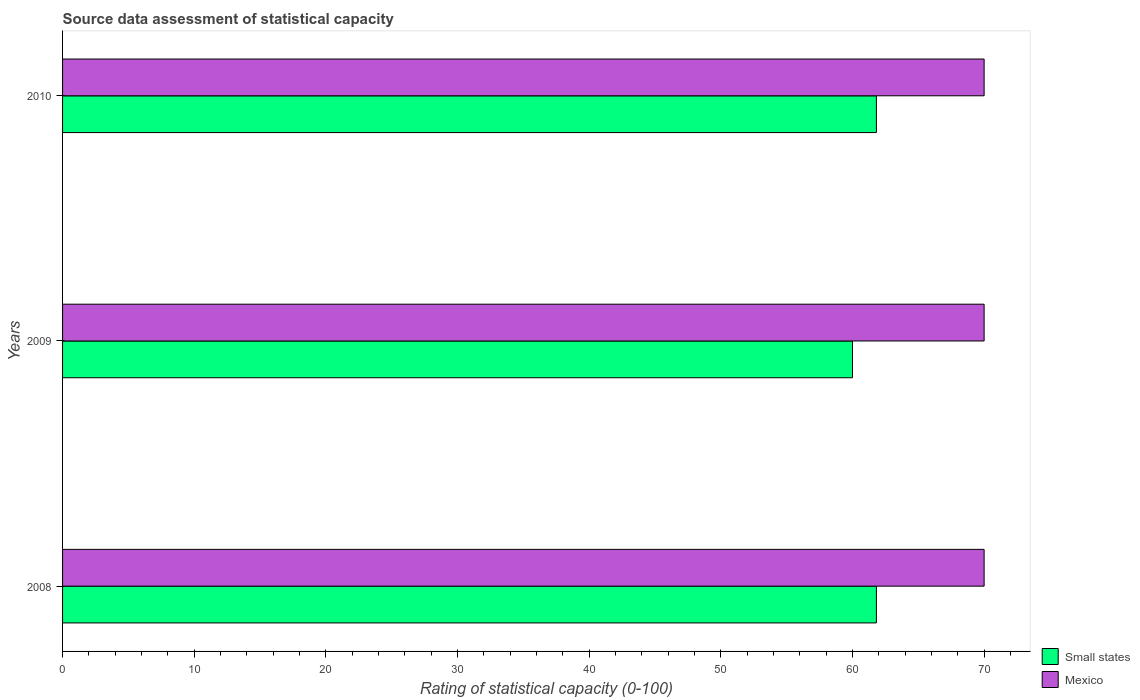How many different coloured bars are there?
Your response must be concise. 2. How many groups of bars are there?
Provide a short and direct response. 3. Are the number of bars per tick equal to the number of legend labels?
Your answer should be compact. Yes. How many bars are there on the 1st tick from the top?
Keep it short and to the point. 2. What is the label of the 2nd group of bars from the top?
Your answer should be compact. 2009. What is the rating of statistical capacity in Mexico in 2010?
Make the answer very short. 70. Across all years, what is the maximum rating of statistical capacity in Mexico?
Offer a terse response. 70. Across all years, what is the minimum rating of statistical capacity in Small states?
Your answer should be very brief. 60. What is the total rating of statistical capacity in Small states in the graph?
Your answer should be compact. 183.64. What is the difference between the rating of statistical capacity in Mexico in 2008 and that in 2009?
Offer a very short reply. 0. What is the difference between the rating of statistical capacity in Small states in 2010 and the rating of statistical capacity in Mexico in 2008?
Keep it short and to the point. -8.18. What is the average rating of statistical capacity in Small states per year?
Offer a very short reply. 61.21. In how many years, is the rating of statistical capacity in Mexico greater than 14 ?
Your response must be concise. 3. Is the rating of statistical capacity in Small states in 2008 less than that in 2010?
Keep it short and to the point. No. What is the difference between the highest and the lowest rating of statistical capacity in Small states?
Ensure brevity in your answer.  1.82. Is the sum of the rating of statistical capacity in Small states in 2009 and 2010 greater than the maximum rating of statistical capacity in Mexico across all years?
Offer a very short reply. Yes. What does the 2nd bar from the top in 2009 represents?
Your answer should be very brief. Small states. What does the 2nd bar from the bottom in 2008 represents?
Offer a very short reply. Mexico. How many bars are there?
Offer a terse response. 6. How many years are there in the graph?
Make the answer very short. 3. What is the difference between two consecutive major ticks on the X-axis?
Provide a short and direct response. 10. Does the graph contain any zero values?
Your answer should be compact. No. Does the graph contain grids?
Your answer should be very brief. No. Where does the legend appear in the graph?
Provide a short and direct response. Bottom right. What is the title of the graph?
Provide a succinct answer. Source data assessment of statistical capacity. Does "Middle East & North Africa (developing only)" appear as one of the legend labels in the graph?
Your answer should be very brief. No. What is the label or title of the X-axis?
Make the answer very short. Rating of statistical capacity (0-100). What is the Rating of statistical capacity (0-100) in Small states in 2008?
Give a very brief answer. 61.82. What is the Rating of statistical capacity (0-100) in Mexico in 2008?
Give a very brief answer. 70. What is the Rating of statistical capacity (0-100) in Small states in 2010?
Offer a terse response. 61.82. Across all years, what is the maximum Rating of statistical capacity (0-100) in Small states?
Give a very brief answer. 61.82. Across all years, what is the maximum Rating of statistical capacity (0-100) in Mexico?
Offer a very short reply. 70. Across all years, what is the minimum Rating of statistical capacity (0-100) in Small states?
Provide a succinct answer. 60. Across all years, what is the minimum Rating of statistical capacity (0-100) in Mexico?
Offer a very short reply. 70. What is the total Rating of statistical capacity (0-100) in Small states in the graph?
Keep it short and to the point. 183.64. What is the total Rating of statistical capacity (0-100) of Mexico in the graph?
Your answer should be very brief. 210. What is the difference between the Rating of statistical capacity (0-100) in Small states in 2008 and that in 2009?
Your answer should be compact. 1.82. What is the difference between the Rating of statistical capacity (0-100) in Mexico in 2008 and that in 2009?
Keep it short and to the point. 0. What is the difference between the Rating of statistical capacity (0-100) in Small states in 2008 and that in 2010?
Ensure brevity in your answer.  0. What is the difference between the Rating of statistical capacity (0-100) in Mexico in 2008 and that in 2010?
Make the answer very short. 0. What is the difference between the Rating of statistical capacity (0-100) of Small states in 2009 and that in 2010?
Your answer should be very brief. -1.82. What is the difference between the Rating of statistical capacity (0-100) of Mexico in 2009 and that in 2010?
Ensure brevity in your answer.  0. What is the difference between the Rating of statistical capacity (0-100) in Small states in 2008 and the Rating of statistical capacity (0-100) in Mexico in 2009?
Your answer should be compact. -8.18. What is the difference between the Rating of statistical capacity (0-100) in Small states in 2008 and the Rating of statistical capacity (0-100) in Mexico in 2010?
Your answer should be compact. -8.18. What is the difference between the Rating of statistical capacity (0-100) of Small states in 2009 and the Rating of statistical capacity (0-100) of Mexico in 2010?
Offer a terse response. -10. What is the average Rating of statistical capacity (0-100) of Small states per year?
Give a very brief answer. 61.21. In the year 2008, what is the difference between the Rating of statistical capacity (0-100) in Small states and Rating of statistical capacity (0-100) in Mexico?
Your response must be concise. -8.18. In the year 2010, what is the difference between the Rating of statistical capacity (0-100) of Small states and Rating of statistical capacity (0-100) of Mexico?
Give a very brief answer. -8.18. What is the ratio of the Rating of statistical capacity (0-100) of Small states in 2008 to that in 2009?
Ensure brevity in your answer.  1.03. What is the ratio of the Rating of statistical capacity (0-100) in Mexico in 2008 to that in 2009?
Ensure brevity in your answer.  1. What is the ratio of the Rating of statistical capacity (0-100) of Small states in 2008 to that in 2010?
Your answer should be compact. 1. What is the ratio of the Rating of statistical capacity (0-100) in Mexico in 2008 to that in 2010?
Offer a very short reply. 1. What is the ratio of the Rating of statistical capacity (0-100) in Small states in 2009 to that in 2010?
Give a very brief answer. 0.97. What is the difference between the highest and the second highest Rating of statistical capacity (0-100) of Small states?
Provide a short and direct response. 0. What is the difference between the highest and the lowest Rating of statistical capacity (0-100) in Small states?
Give a very brief answer. 1.82. 